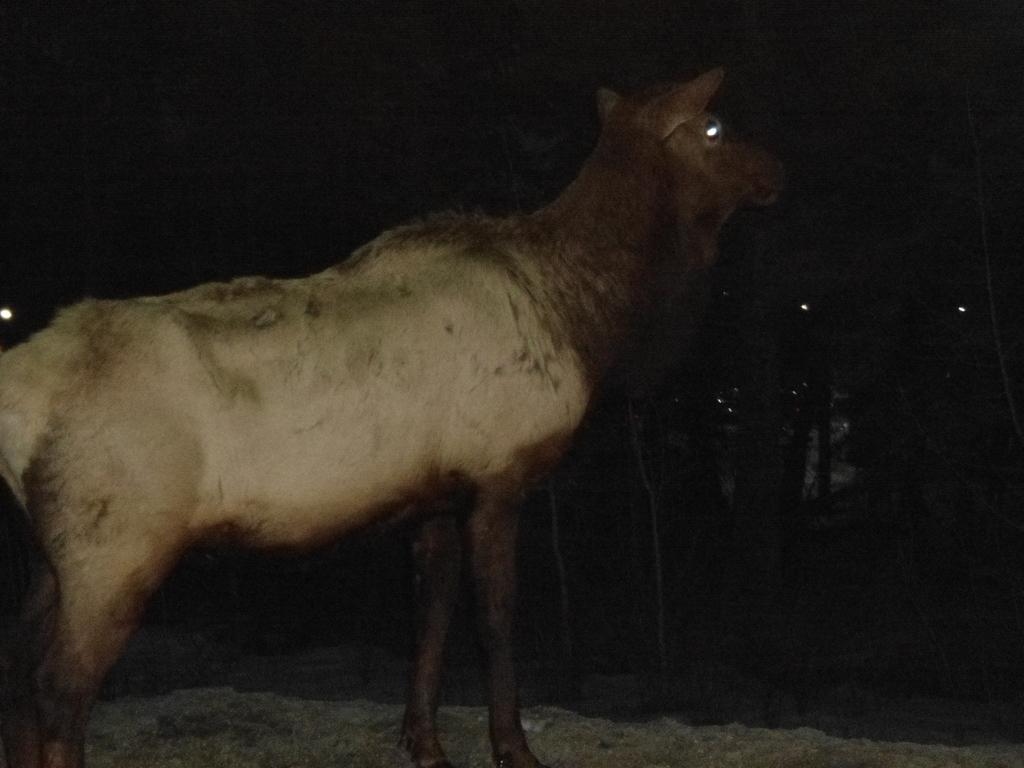What type of animal is present in the image? There is a deer in the image. What type of crayon is the deer holding in the image? There is no crayon present in the image, and the deer is not holding anything. 